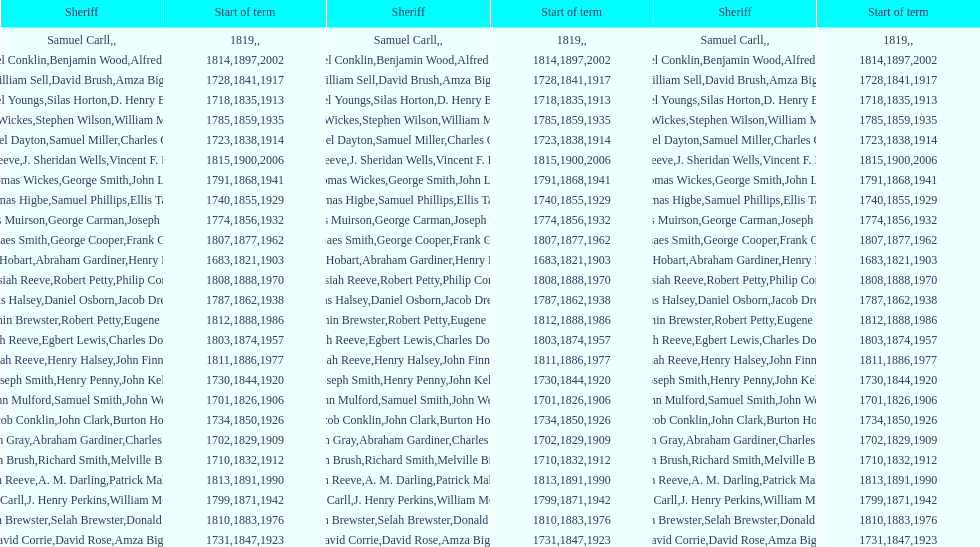How many sheriff's have the last name biggs? 1. 